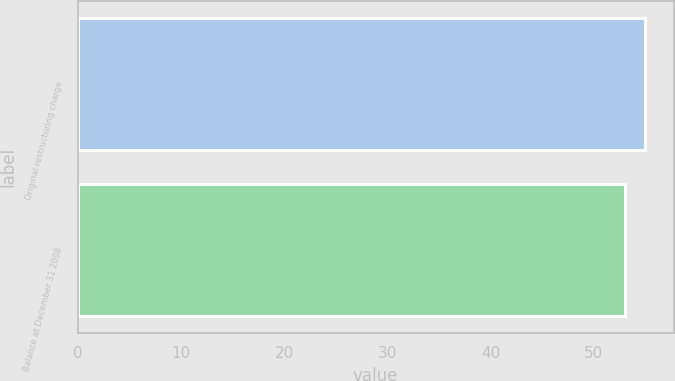Convert chart to OTSL. <chart><loc_0><loc_0><loc_500><loc_500><bar_chart><fcel>Original restructuring charge<fcel>Balance at December 31 2008<nl><fcel>55<fcel>53<nl></chart> 